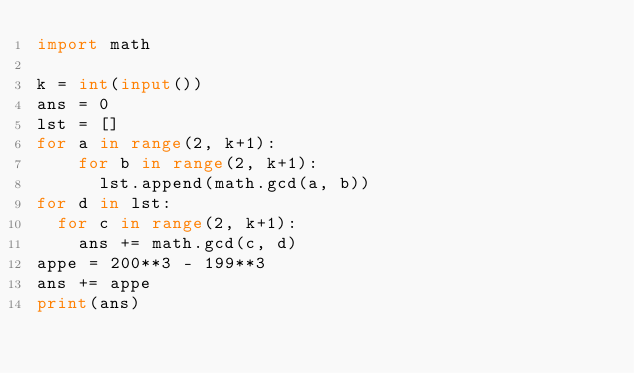<code> <loc_0><loc_0><loc_500><loc_500><_Python_>import math

k = int(input())
ans = 0
lst = []
for a in range(2, k+1):
    for b in range(2, k+1):
      lst.append(math.gcd(a, b))
for d in lst:
  for c in range(2, k+1):
    ans += math.gcd(c, d)
appe = 200**3 - 199**3
ans += appe
print(ans)</code> 